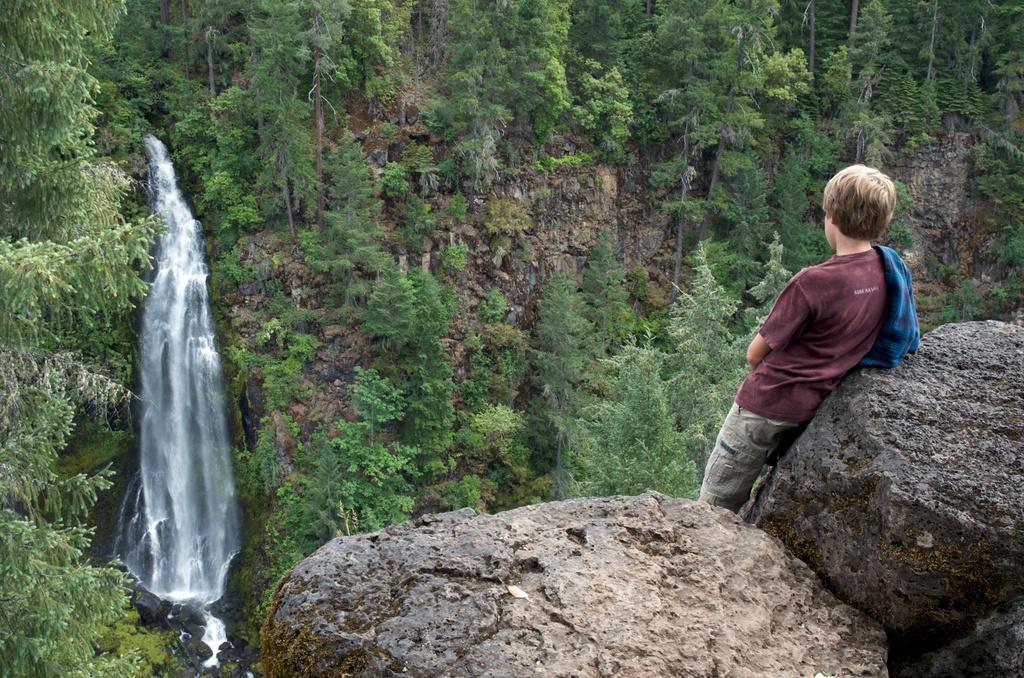Could you give a brief overview of what you see in this image? In this image I can see few huge rocks and a person standing behind the rocks. I can see the waterfall and few trees which are green in color. 